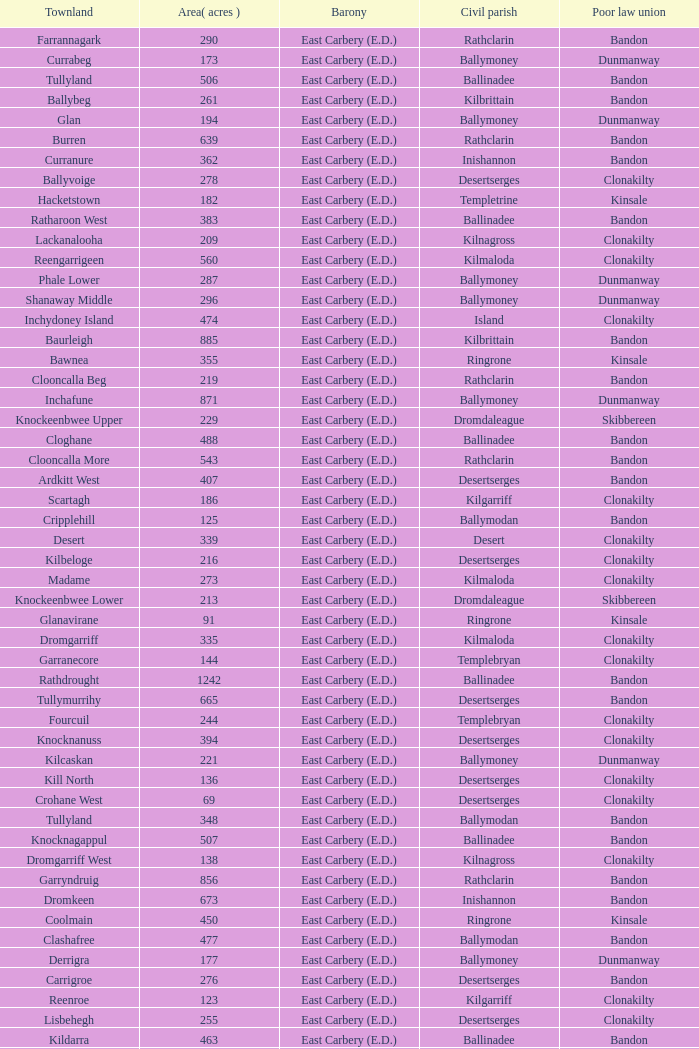What is the poor law union of the Kilmaloda townland? Clonakilty. 